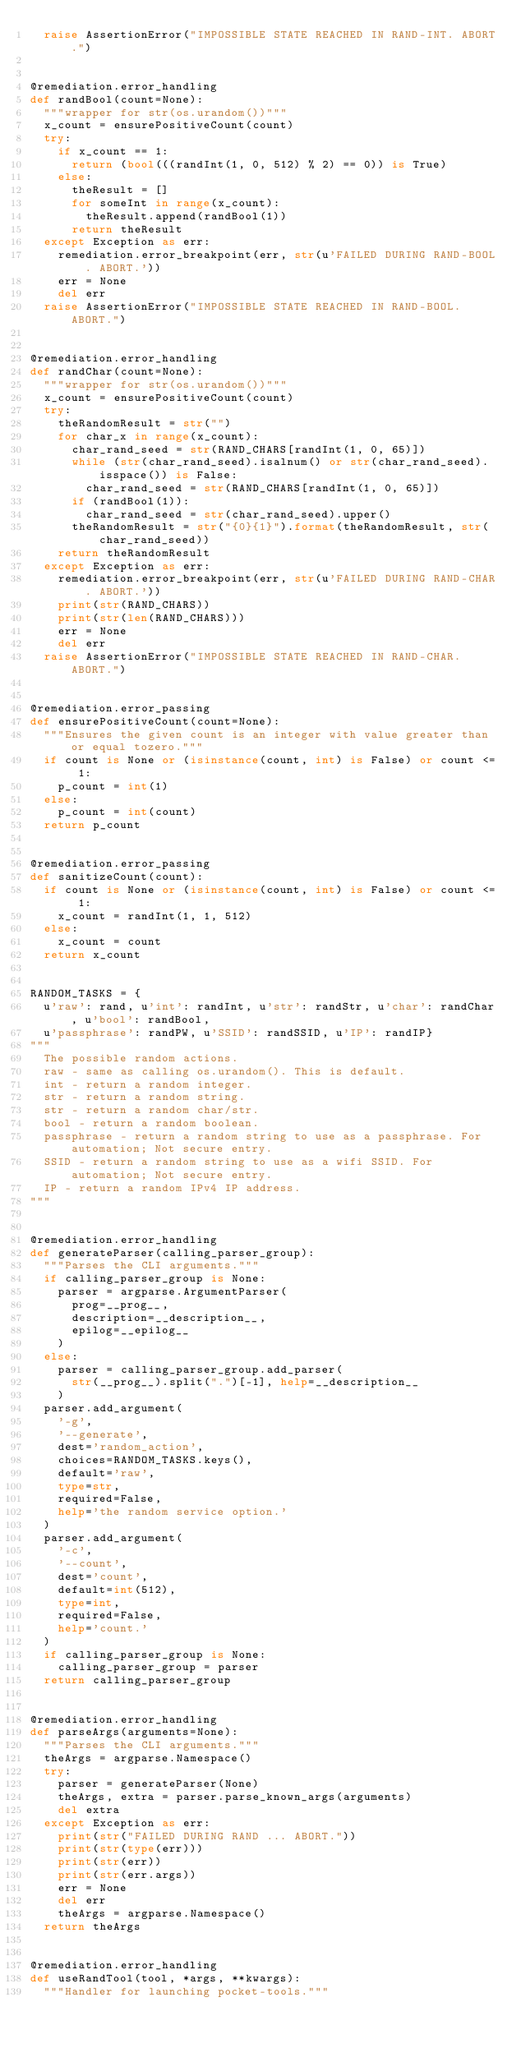<code> <loc_0><loc_0><loc_500><loc_500><_Python_>	raise AssertionError("IMPOSSIBLE STATE REACHED IN RAND-INT. ABORT.")


@remediation.error_handling
def randBool(count=None):
	"""wrapper for str(os.urandom())"""
	x_count = ensurePositiveCount(count)
	try:
		if x_count == 1:
			return (bool(((randInt(1, 0, 512) % 2) == 0)) is True)
		else:
			theResult = []
			for someInt in range(x_count):
				theResult.append(randBool(1))
			return theResult
	except Exception as err:
		remediation.error_breakpoint(err, str(u'FAILED DURING RAND-BOOL. ABORT.'))
		err = None
		del err
	raise AssertionError("IMPOSSIBLE STATE REACHED IN RAND-BOOL. ABORT.")


@remediation.error_handling
def randChar(count=None):
	"""wrapper for str(os.urandom())"""
	x_count = ensurePositiveCount(count)
	try:
		theRandomResult = str("")
		for char_x in range(x_count):
			char_rand_seed = str(RAND_CHARS[randInt(1, 0, 65)])
			while (str(char_rand_seed).isalnum() or str(char_rand_seed).isspace()) is False:
				char_rand_seed = str(RAND_CHARS[randInt(1, 0, 65)])
			if (randBool(1)):
				char_rand_seed = str(char_rand_seed).upper()
			theRandomResult = str("{0}{1}").format(theRandomResult, str(char_rand_seed))
		return theRandomResult
	except Exception as err:
		remediation.error_breakpoint(err, str(u'FAILED DURING RAND-CHAR. ABORT.'))
		print(str(RAND_CHARS))
		print(str(len(RAND_CHARS)))
		err = None
		del err
	raise AssertionError("IMPOSSIBLE STATE REACHED IN RAND-CHAR. ABORT.")


@remediation.error_passing
def ensurePositiveCount(count=None):
	"""Ensures the given count is an integer with value greater than or equal tozero."""
	if count is None or (isinstance(count, int) is False) or count <= 1:
		p_count = int(1)
	else:
		p_count = int(count)
	return p_count


@remediation.error_passing
def sanitizeCount(count):
	if count is None or (isinstance(count, int) is False) or count <= 1:
		x_count = randInt(1, 1, 512)
	else:
		x_count = count
	return x_count


RANDOM_TASKS = {
	u'raw': rand, u'int': randInt, u'str': randStr, u'char': randChar, u'bool': randBool,
	u'passphrase': randPW, u'SSID': randSSID, u'IP': randIP}
"""
	The possible random actions.
	raw - same as calling os.urandom(). This is default.
	int - return a random integer.
	str - return a random string.
	str - return a random char/str.
	bool - return a random boolean.
	passphrase - return a random string to use as a passphrase. For automation; Not secure entry.
	SSID - return a random string to use as a wifi SSID. For automation; Not secure entry.
	IP - return a random IPv4 IP address.
"""


@remediation.error_handling
def generateParser(calling_parser_group):
	"""Parses the CLI arguments."""
	if calling_parser_group is None:
		parser = argparse.ArgumentParser(
			prog=__prog__,
			description=__description__,
			epilog=__epilog__
		)
	else:
		parser = calling_parser_group.add_parser(
			str(__prog__).split(".")[-1], help=__description__
		)
	parser.add_argument(
		'-g',
		'--generate',
		dest='random_action',
		choices=RANDOM_TASKS.keys(),
		default='raw',
		type=str,
		required=False,
		help='the random service option.'
	)
	parser.add_argument(
		'-c',
		'--count',
		dest='count',
		default=int(512),
		type=int,
		required=False,
		help='count.'
	)
	if calling_parser_group is None:
		calling_parser_group = parser
	return calling_parser_group


@remediation.error_handling
def parseArgs(arguments=None):
	"""Parses the CLI arguments."""
	theArgs = argparse.Namespace()
	try:
		parser = generateParser(None)
		theArgs, extra = parser.parse_known_args(arguments)
		del extra
	except Exception as err:
		print(str("FAILED DURING RAND ... ABORT."))
		print(str(type(err)))
		print(str(err))
		print(str(err.args))
		err = None
		del err
		theArgs = argparse.Namespace()
	return theArgs


@remediation.error_handling
def useRandTool(tool, *args, **kwargs):
	"""Handler for launching pocket-tools."""</code> 